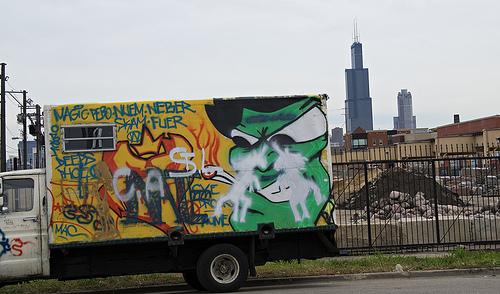How many buildings are behind the truck?
Write a very short answer. 2. Is the painting on the bus deliberate?
Answer briefly. Yes. What kind of writing is on the truck?
Keep it brief. Graffiti. Any people around?
Keep it brief. No. 